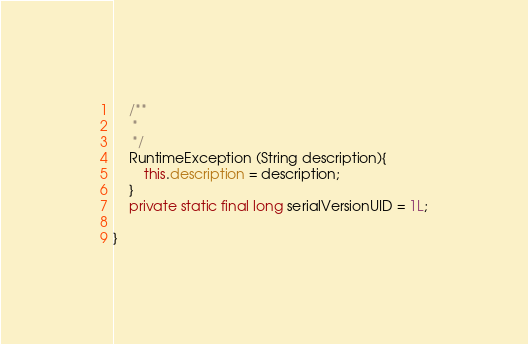<code> <loc_0><loc_0><loc_500><loc_500><_Java_>    /**
     * 
     */
    RuntimeException (String description){
        this.description = description;
    }
    private static final long serialVersionUID = 1L;

}
</code> 